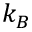Convert formula to latex. <formula><loc_0><loc_0><loc_500><loc_500>k _ { B }</formula> 